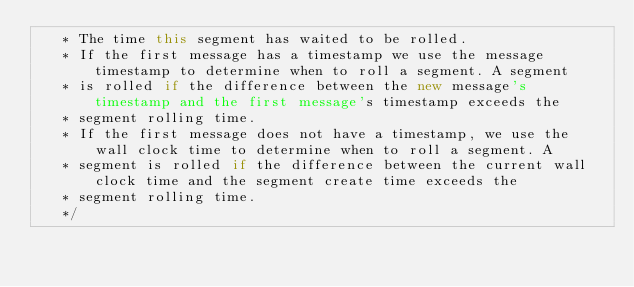<code> <loc_0><loc_0><loc_500><loc_500><_Scala_>   * The time this segment has waited to be rolled.
   * If the first message has a timestamp we use the message timestamp to determine when to roll a segment. A segment
   * is rolled if the difference between the new message's timestamp and the first message's timestamp exceeds the
   * segment rolling time.
   * If the first message does not have a timestamp, we use the wall clock time to determine when to roll a segment. A
   * segment is rolled if the difference between the current wall clock time and the segment create time exceeds the
   * segment rolling time.
   */</code> 